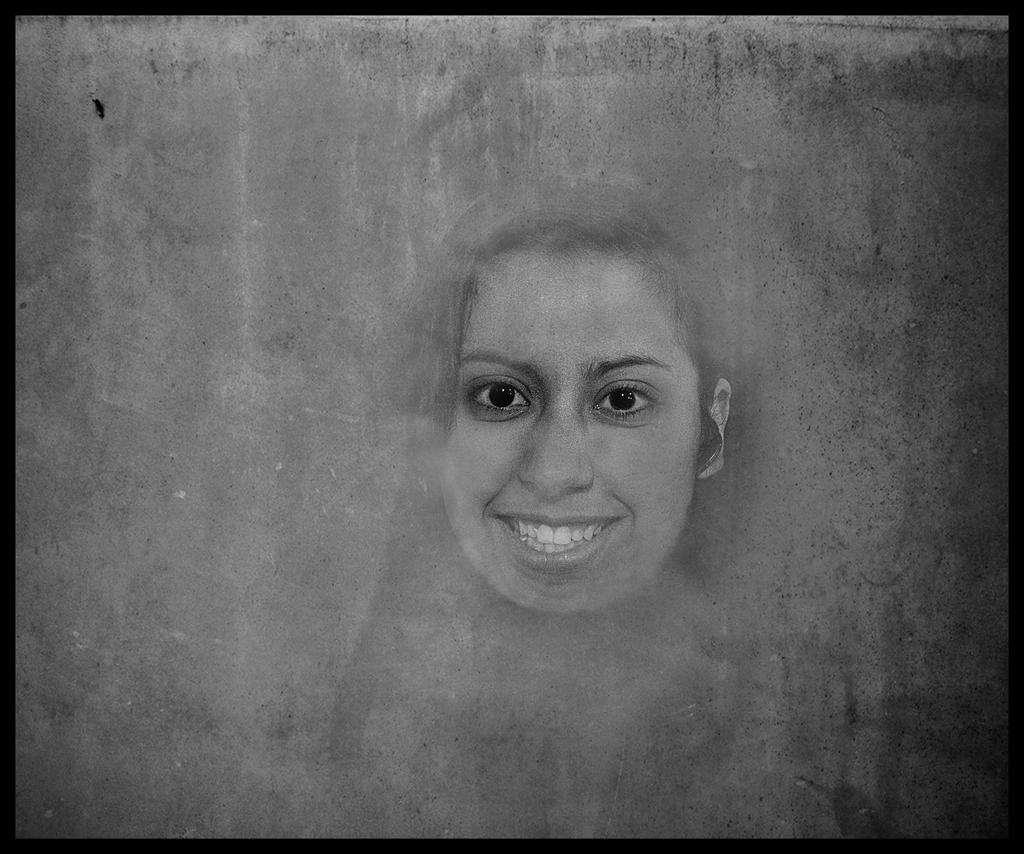What type of art is depicted in the image? The image is a pencil art of a person. What color scheme is used in the pencil art? The pencil art is in black and white. What expression does the person in the art have? The person in the art is smiling. What type of agreement is being discussed in the pencil art? There is no discussion or agreement present in the pencil art; it is a static image of a person smiling. How does the zephyr affect the person in the pencil art? There is no mention of a zephyr or any weather-related elements in the pencil art; it is a simple drawing of a person smiling. 